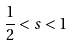Convert formula to latex. <formula><loc_0><loc_0><loc_500><loc_500>\frac { 1 } { 2 } < s < 1</formula> 